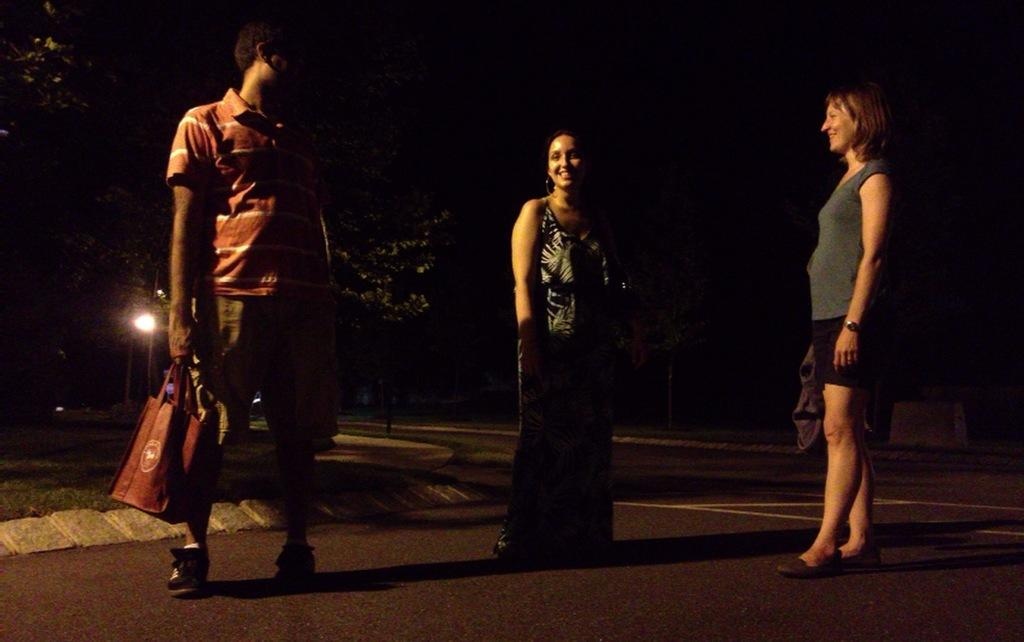How many people are in the image? There are three people in the image: one man and two women. What are the people doing in the image? The people are standing on the road. What is the time of day in the image? The scene takes place at night time. What can be seen in the background of the image? There are trees and a street light in the background of the image. What type of paste is being used by the sisters in the image? There are no sisters present in the image, and no paste is being used. 